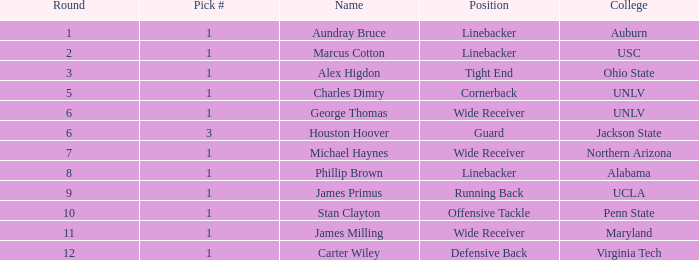George thomas was chosen in which round? 6.0. 